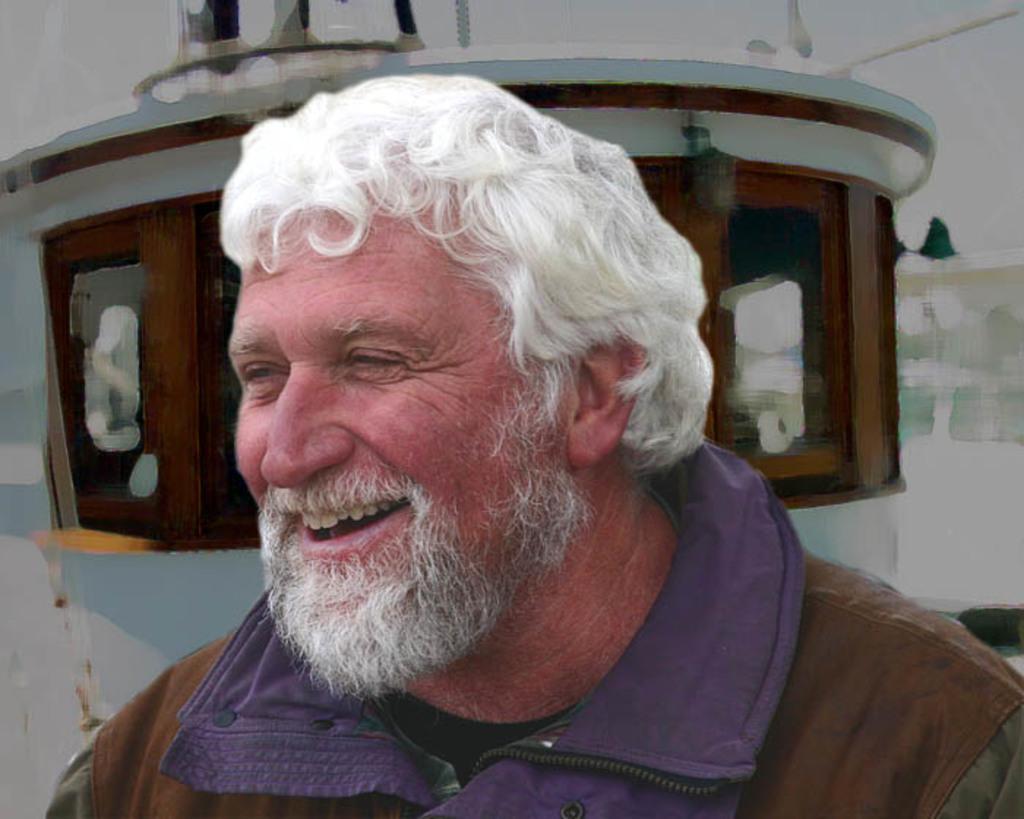Describe this image in one or two sentences. In this picture there is a man in the center of the image, it seems to be a poster in the background area of the image. 